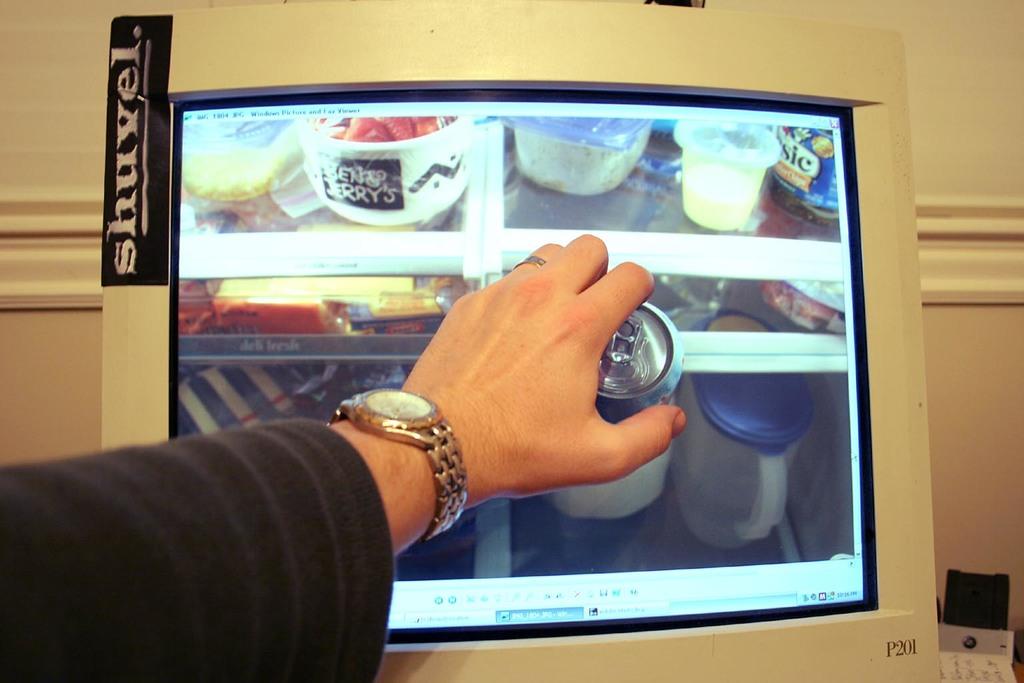What does the sticker say?
Your answer should be compact. Shuvel. 